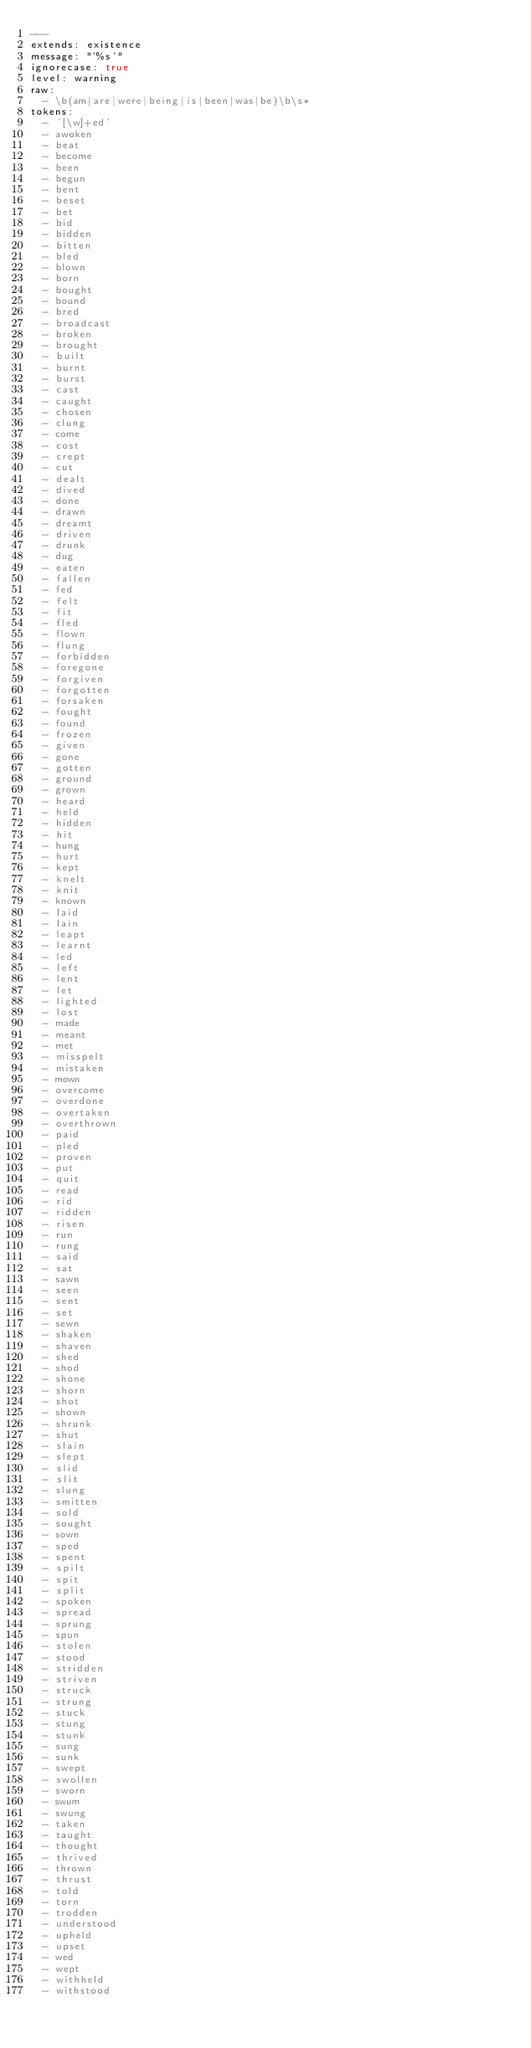Convert code to text. <code><loc_0><loc_0><loc_500><loc_500><_YAML_>---
extends: existence
message: "'%s'"
ignorecase: true
level: warning
raw:
  - \b(am|are|were|being|is|been|was|be)\b\s*
tokens:
  - '[\w]+ed'
  - awoken
  - beat
  - become
  - been
  - begun
  - bent
  - beset
  - bet
  - bid
  - bidden
  - bitten
  - bled
  - blown
  - born
  - bought
  - bound
  - bred
  - broadcast
  - broken
  - brought
  - built
  - burnt
  - burst
  - cast
  - caught
  - chosen
  - clung
  - come
  - cost
  - crept
  - cut
  - dealt
  - dived
  - done
  - drawn
  - dreamt
  - driven
  - drunk
  - dug
  - eaten
  - fallen
  - fed
  - felt
  - fit
  - fled
  - flown
  - flung
  - forbidden
  - foregone
  - forgiven
  - forgotten
  - forsaken
  - fought
  - found
  - frozen
  - given
  - gone
  - gotten
  - ground
  - grown
  - heard
  - held
  - hidden
  - hit
  - hung
  - hurt
  - kept
  - knelt
  - knit
  - known
  - laid
  - lain
  - leapt
  - learnt
  - led
  - left
  - lent
  - let
  - lighted
  - lost
  - made
  - meant
  - met
  - misspelt
  - mistaken
  - mown
  - overcome
  - overdone
  - overtaken
  - overthrown
  - paid
  - pled
  - proven
  - put
  - quit
  - read
  - rid
  - ridden
  - risen
  - run
  - rung
  - said
  - sat
  - sawn
  - seen
  - sent
  - set
  - sewn
  - shaken
  - shaven
  - shed
  - shod
  - shone
  - shorn
  - shot
  - shown
  - shrunk
  - shut
  - slain
  - slept
  - slid
  - slit
  - slung
  - smitten
  - sold
  - sought
  - sown
  - sped
  - spent
  - spilt
  - spit
  - split
  - spoken
  - spread
  - sprung
  - spun
  - stolen
  - stood
  - stridden
  - striven
  - struck
  - strung
  - stuck
  - stung
  - stunk
  - sung
  - sunk
  - swept
  - swollen
  - sworn
  - swum
  - swung
  - taken
  - taught
  - thought
  - thrived
  - thrown
  - thrust
  - told
  - torn
  - trodden
  - understood
  - upheld
  - upset
  - wed
  - wept
  - withheld
  - withstood</code> 